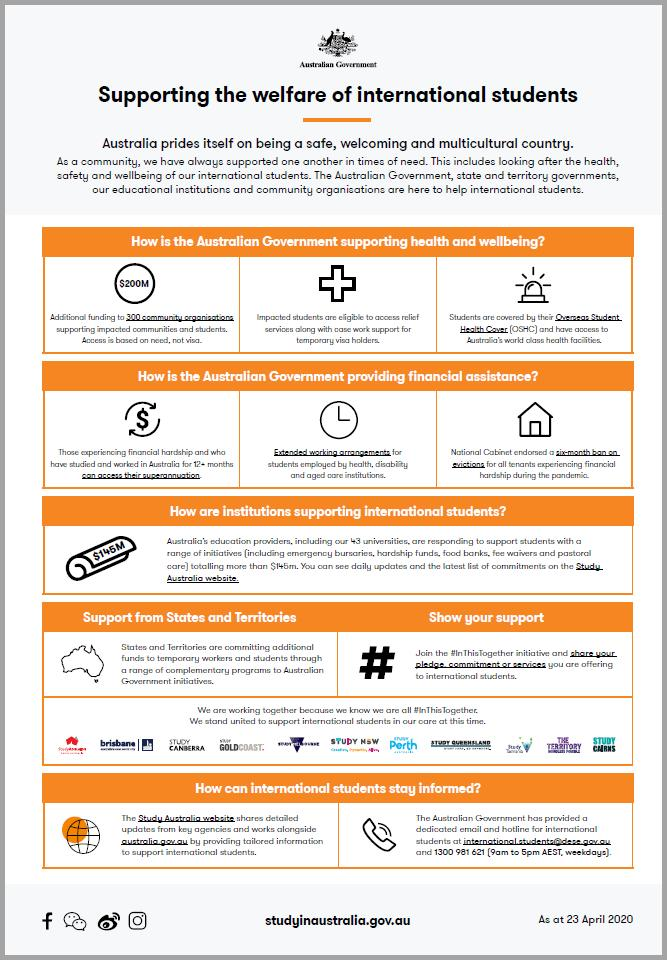Identify some key points in this picture. There are five points under the heading "Supporting the welfare of international students". 